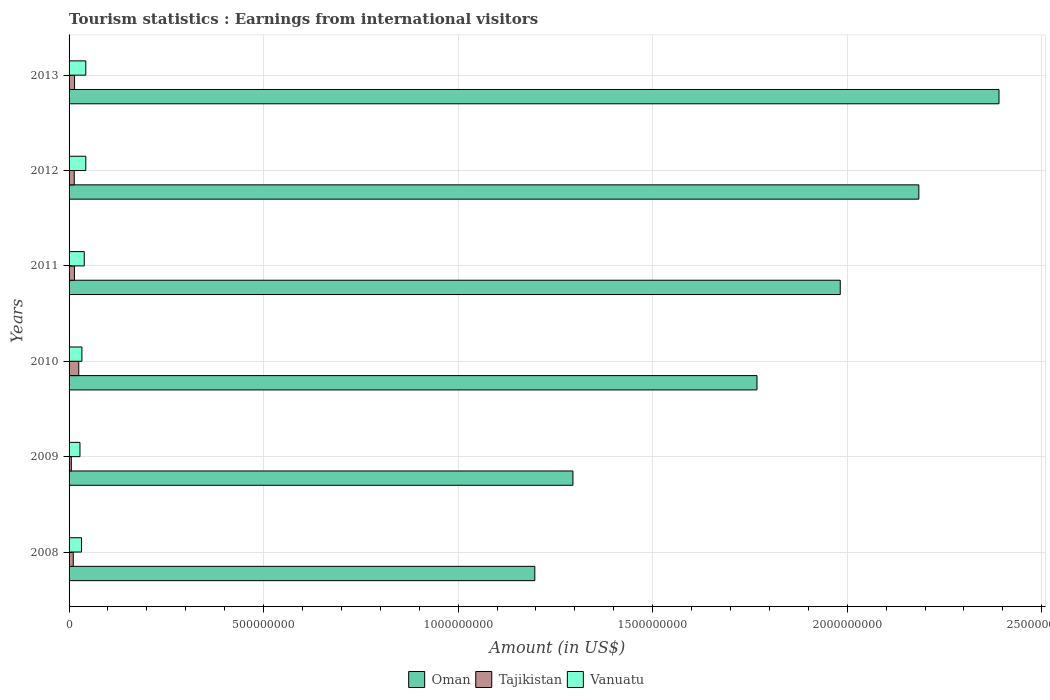Are the number of bars on each tick of the Y-axis equal?
Provide a short and direct response. Yes. How many bars are there on the 4th tick from the top?
Keep it short and to the point. 3. What is the earnings from international visitors in Vanuatu in 2010?
Your answer should be very brief. 3.30e+07. Across all years, what is the maximum earnings from international visitors in Vanuatu?
Your answer should be compact. 4.30e+07. Across all years, what is the minimum earnings from international visitors in Tajikistan?
Provide a succinct answer. 5.80e+06. In which year was the earnings from international visitors in Tajikistan minimum?
Offer a very short reply. 2009. What is the total earnings from international visitors in Tajikistan in the graph?
Provide a short and direct response. 8.27e+07. What is the difference between the earnings from international visitors in Oman in 2010 and that in 2012?
Ensure brevity in your answer.  -4.16e+08. What is the difference between the earnings from international visitors in Oman in 2011 and the earnings from international visitors in Tajikistan in 2013?
Make the answer very short. 1.97e+09. What is the average earnings from international visitors in Vanuatu per year?
Provide a short and direct response. 3.63e+07. In the year 2011, what is the difference between the earnings from international visitors in Tajikistan and earnings from international visitors in Oman?
Provide a succinct answer. -1.97e+09. In how many years, is the earnings from international visitors in Vanuatu greater than 1000000000 US$?
Offer a terse response. 0. What is the ratio of the earnings from international visitors in Oman in 2008 to that in 2010?
Your answer should be compact. 0.68. Is the earnings from international visitors in Vanuatu in 2009 less than that in 2011?
Provide a succinct answer. Yes. What is the difference between the highest and the second highest earnings from international visitors in Oman?
Your answer should be very brief. 2.06e+08. What is the difference between the highest and the lowest earnings from international visitors in Tajikistan?
Make the answer very short. 1.91e+07. In how many years, is the earnings from international visitors in Tajikistan greater than the average earnings from international visitors in Tajikistan taken over all years?
Your answer should be very brief. 3. What does the 2nd bar from the top in 2011 represents?
Ensure brevity in your answer.  Tajikistan. What does the 1st bar from the bottom in 2013 represents?
Keep it short and to the point. Oman. Is it the case that in every year, the sum of the earnings from international visitors in Oman and earnings from international visitors in Vanuatu is greater than the earnings from international visitors in Tajikistan?
Your response must be concise. Yes. How many years are there in the graph?
Provide a succinct answer. 6. Are the values on the major ticks of X-axis written in scientific E-notation?
Provide a succinct answer. No. Where does the legend appear in the graph?
Offer a terse response. Bottom center. How many legend labels are there?
Offer a terse response. 3. How are the legend labels stacked?
Your response must be concise. Horizontal. What is the title of the graph?
Offer a very short reply. Tourism statistics : Earnings from international visitors. Does "Marshall Islands" appear as one of the legend labels in the graph?
Ensure brevity in your answer.  No. What is the label or title of the Y-axis?
Make the answer very short. Years. What is the Amount (in US$) in Oman in 2008?
Make the answer very short. 1.20e+09. What is the Amount (in US$) in Tajikistan in 2008?
Give a very brief answer. 1.08e+07. What is the Amount (in US$) in Vanuatu in 2008?
Your answer should be very brief. 3.20e+07. What is the Amount (in US$) in Oman in 2009?
Your response must be concise. 1.30e+09. What is the Amount (in US$) of Tajikistan in 2009?
Ensure brevity in your answer.  5.80e+06. What is the Amount (in US$) of Vanuatu in 2009?
Provide a succinct answer. 2.80e+07. What is the Amount (in US$) in Oman in 2010?
Keep it short and to the point. 1.77e+09. What is the Amount (in US$) of Tajikistan in 2010?
Offer a very short reply. 2.49e+07. What is the Amount (in US$) of Vanuatu in 2010?
Your answer should be compact. 3.30e+07. What is the Amount (in US$) of Oman in 2011?
Give a very brief answer. 1.98e+09. What is the Amount (in US$) in Tajikistan in 2011?
Give a very brief answer. 1.38e+07. What is the Amount (in US$) in Vanuatu in 2011?
Give a very brief answer. 3.90e+07. What is the Amount (in US$) in Oman in 2012?
Give a very brief answer. 2.18e+09. What is the Amount (in US$) of Tajikistan in 2012?
Your answer should be compact. 1.33e+07. What is the Amount (in US$) of Vanuatu in 2012?
Provide a succinct answer. 4.30e+07. What is the Amount (in US$) of Oman in 2013?
Provide a short and direct response. 2.39e+09. What is the Amount (in US$) of Tajikistan in 2013?
Keep it short and to the point. 1.41e+07. What is the Amount (in US$) in Vanuatu in 2013?
Your answer should be very brief. 4.30e+07. Across all years, what is the maximum Amount (in US$) in Oman?
Make the answer very short. 2.39e+09. Across all years, what is the maximum Amount (in US$) in Tajikistan?
Your answer should be very brief. 2.49e+07. Across all years, what is the maximum Amount (in US$) of Vanuatu?
Your answer should be very brief. 4.30e+07. Across all years, what is the minimum Amount (in US$) in Oman?
Ensure brevity in your answer.  1.20e+09. Across all years, what is the minimum Amount (in US$) of Tajikistan?
Give a very brief answer. 5.80e+06. Across all years, what is the minimum Amount (in US$) in Vanuatu?
Your answer should be compact. 2.80e+07. What is the total Amount (in US$) in Oman in the graph?
Offer a very short reply. 1.08e+1. What is the total Amount (in US$) of Tajikistan in the graph?
Provide a succinct answer. 8.27e+07. What is the total Amount (in US$) in Vanuatu in the graph?
Keep it short and to the point. 2.18e+08. What is the difference between the Amount (in US$) of Oman in 2008 and that in 2009?
Your answer should be compact. -9.80e+07. What is the difference between the Amount (in US$) of Vanuatu in 2008 and that in 2009?
Your answer should be very brief. 4.00e+06. What is the difference between the Amount (in US$) of Oman in 2008 and that in 2010?
Offer a very short reply. -5.71e+08. What is the difference between the Amount (in US$) in Tajikistan in 2008 and that in 2010?
Your response must be concise. -1.41e+07. What is the difference between the Amount (in US$) in Oman in 2008 and that in 2011?
Keep it short and to the point. -7.85e+08. What is the difference between the Amount (in US$) in Vanuatu in 2008 and that in 2011?
Provide a short and direct response. -7.00e+06. What is the difference between the Amount (in US$) in Oman in 2008 and that in 2012?
Your answer should be compact. -9.87e+08. What is the difference between the Amount (in US$) in Tajikistan in 2008 and that in 2012?
Provide a short and direct response. -2.50e+06. What is the difference between the Amount (in US$) of Vanuatu in 2008 and that in 2012?
Provide a succinct answer. -1.10e+07. What is the difference between the Amount (in US$) of Oman in 2008 and that in 2013?
Your response must be concise. -1.19e+09. What is the difference between the Amount (in US$) in Tajikistan in 2008 and that in 2013?
Your answer should be very brief. -3.30e+06. What is the difference between the Amount (in US$) in Vanuatu in 2008 and that in 2013?
Provide a short and direct response. -1.10e+07. What is the difference between the Amount (in US$) of Oman in 2009 and that in 2010?
Give a very brief answer. -4.73e+08. What is the difference between the Amount (in US$) in Tajikistan in 2009 and that in 2010?
Your answer should be very brief. -1.91e+07. What is the difference between the Amount (in US$) in Vanuatu in 2009 and that in 2010?
Your response must be concise. -5.00e+06. What is the difference between the Amount (in US$) of Oman in 2009 and that in 2011?
Ensure brevity in your answer.  -6.87e+08. What is the difference between the Amount (in US$) in Tajikistan in 2009 and that in 2011?
Keep it short and to the point. -8.00e+06. What is the difference between the Amount (in US$) of Vanuatu in 2009 and that in 2011?
Your answer should be very brief. -1.10e+07. What is the difference between the Amount (in US$) of Oman in 2009 and that in 2012?
Give a very brief answer. -8.89e+08. What is the difference between the Amount (in US$) of Tajikistan in 2009 and that in 2012?
Provide a short and direct response. -7.50e+06. What is the difference between the Amount (in US$) of Vanuatu in 2009 and that in 2012?
Make the answer very short. -1.50e+07. What is the difference between the Amount (in US$) of Oman in 2009 and that in 2013?
Make the answer very short. -1.10e+09. What is the difference between the Amount (in US$) in Tajikistan in 2009 and that in 2013?
Your answer should be very brief. -8.30e+06. What is the difference between the Amount (in US$) of Vanuatu in 2009 and that in 2013?
Your response must be concise. -1.50e+07. What is the difference between the Amount (in US$) of Oman in 2010 and that in 2011?
Make the answer very short. -2.14e+08. What is the difference between the Amount (in US$) of Tajikistan in 2010 and that in 2011?
Your answer should be very brief. 1.11e+07. What is the difference between the Amount (in US$) of Vanuatu in 2010 and that in 2011?
Your answer should be very brief. -6.00e+06. What is the difference between the Amount (in US$) in Oman in 2010 and that in 2012?
Provide a short and direct response. -4.16e+08. What is the difference between the Amount (in US$) in Tajikistan in 2010 and that in 2012?
Ensure brevity in your answer.  1.16e+07. What is the difference between the Amount (in US$) in Vanuatu in 2010 and that in 2012?
Offer a terse response. -1.00e+07. What is the difference between the Amount (in US$) in Oman in 2010 and that in 2013?
Provide a succinct answer. -6.22e+08. What is the difference between the Amount (in US$) of Tajikistan in 2010 and that in 2013?
Provide a short and direct response. 1.08e+07. What is the difference between the Amount (in US$) in Vanuatu in 2010 and that in 2013?
Your answer should be very brief. -1.00e+07. What is the difference between the Amount (in US$) in Oman in 2011 and that in 2012?
Offer a terse response. -2.02e+08. What is the difference between the Amount (in US$) in Oman in 2011 and that in 2013?
Make the answer very short. -4.08e+08. What is the difference between the Amount (in US$) in Oman in 2012 and that in 2013?
Ensure brevity in your answer.  -2.06e+08. What is the difference between the Amount (in US$) of Tajikistan in 2012 and that in 2013?
Your answer should be very brief. -8.00e+05. What is the difference between the Amount (in US$) of Vanuatu in 2012 and that in 2013?
Give a very brief answer. 0. What is the difference between the Amount (in US$) in Oman in 2008 and the Amount (in US$) in Tajikistan in 2009?
Your answer should be compact. 1.19e+09. What is the difference between the Amount (in US$) in Oman in 2008 and the Amount (in US$) in Vanuatu in 2009?
Offer a terse response. 1.17e+09. What is the difference between the Amount (in US$) of Tajikistan in 2008 and the Amount (in US$) of Vanuatu in 2009?
Provide a succinct answer. -1.72e+07. What is the difference between the Amount (in US$) in Oman in 2008 and the Amount (in US$) in Tajikistan in 2010?
Your response must be concise. 1.17e+09. What is the difference between the Amount (in US$) of Oman in 2008 and the Amount (in US$) of Vanuatu in 2010?
Offer a very short reply. 1.16e+09. What is the difference between the Amount (in US$) of Tajikistan in 2008 and the Amount (in US$) of Vanuatu in 2010?
Make the answer very short. -2.22e+07. What is the difference between the Amount (in US$) in Oman in 2008 and the Amount (in US$) in Tajikistan in 2011?
Your answer should be very brief. 1.18e+09. What is the difference between the Amount (in US$) of Oman in 2008 and the Amount (in US$) of Vanuatu in 2011?
Ensure brevity in your answer.  1.16e+09. What is the difference between the Amount (in US$) in Tajikistan in 2008 and the Amount (in US$) in Vanuatu in 2011?
Your answer should be compact. -2.82e+07. What is the difference between the Amount (in US$) in Oman in 2008 and the Amount (in US$) in Tajikistan in 2012?
Make the answer very short. 1.18e+09. What is the difference between the Amount (in US$) of Oman in 2008 and the Amount (in US$) of Vanuatu in 2012?
Keep it short and to the point. 1.15e+09. What is the difference between the Amount (in US$) of Tajikistan in 2008 and the Amount (in US$) of Vanuatu in 2012?
Offer a very short reply. -3.22e+07. What is the difference between the Amount (in US$) of Oman in 2008 and the Amount (in US$) of Tajikistan in 2013?
Your answer should be compact. 1.18e+09. What is the difference between the Amount (in US$) in Oman in 2008 and the Amount (in US$) in Vanuatu in 2013?
Provide a short and direct response. 1.15e+09. What is the difference between the Amount (in US$) of Tajikistan in 2008 and the Amount (in US$) of Vanuatu in 2013?
Provide a succinct answer. -3.22e+07. What is the difference between the Amount (in US$) of Oman in 2009 and the Amount (in US$) of Tajikistan in 2010?
Keep it short and to the point. 1.27e+09. What is the difference between the Amount (in US$) in Oman in 2009 and the Amount (in US$) in Vanuatu in 2010?
Your answer should be very brief. 1.26e+09. What is the difference between the Amount (in US$) in Tajikistan in 2009 and the Amount (in US$) in Vanuatu in 2010?
Your response must be concise. -2.72e+07. What is the difference between the Amount (in US$) in Oman in 2009 and the Amount (in US$) in Tajikistan in 2011?
Ensure brevity in your answer.  1.28e+09. What is the difference between the Amount (in US$) of Oman in 2009 and the Amount (in US$) of Vanuatu in 2011?
Provide a short and direct response. 1.26e+09. What is the difference between the Amount (in US$) in Tajikistan in 2009 and the Amount (in US$) in Vanuatu in 2011?
Provide a short and direct response. -3.32e+07. What is the difference between the Amount (in US$) of Oman in 2009 and the Amount (in US$) of Tajikistan in 2012?
Your answer should be compact. 1.28e+09. What is the difference between the Amount (in US$) of Oman in 2009 and the Amount (in US$) of Vanuatu in 2012?
Your answer should be very brief. 1.25e+09. What is the difference between the Amount (in US$) of Tajikistan in 2009 and the Amount (in US$) of Vanuatu in 2012?
Keep it short and to the point. -3.72e+07. What is the difference between the Amount (in US$) in Oman in 2009 and the Amount (in US$) in Tajikistan in 2013?
Ensure brevity in your answer.  1.28e+09. What is the difference between the Amount (in US$) of Oman in 2009 and the Amount (in US$) of Vanuatu in 2013?
Offer a terse response. 1.25e+09. What is the difference between the Amount (in US$) in Tajikistan in 2009 and the Amount (in US$) in Vanuatu in 2013?
Provide a short and direct response. -3.72e+07. What is the difference between the Amount (in US$) of Oman in 2010 and the Amount (in US$) of Tajikistan in 2011?
Provide a succinct answer. 1.75e+09. What is the difference between the Amount (in US$) of Oman in 2010 and the Amount (in US$) of Vanuatu in 2011?
Offer a very short reply. 1.73e+09. What is the difference between the Amount (in US$) in Tajikistan in 2010 and the Amount (in US$) in Vanuatu in 2011?
Offer a terse response. -1.41e+07. What is the difference between the Amount (in US$) in Oman in 2010 and the Amount (in US$) in Tajikistan in 2012?
Your answer should be compact. 1.75e+09. What is the difference between the Amount (in US$) in Oman in 2010 and the Amount (in US$) in Vanuatu in 2012?
Keep it short and to the point. 1.72e+09. What is the difference between the Amount (in US$) of Tajikistan in 2010 and the Amount (in US$) of Vanuatu in 2012?
Offer a terse response. -1.81e+07. What is the difference between the Amount (in US$) in Oman in 2010 and the Amount (in US$) in Tajikistan in 2013?
Offer a terse response. 1.75e+09. What is the difference between the Amount (in US$) of Oman in 2010 and the Amount (in US$) of Vanuatu in 2013?
Provide a short and direct response. 1.72e+09. What is the difference between the Amount (in US$) in Tajikistan in 2010 and the Amount (in US$) in Vanuatu in 2013?
Provide a short and direct response. -1.81e+07. What is the difference between the Amount (in US$) of Oman in 2011 and the Amount (in US$) of Tajikistan in 2012?
Your answer should be compact. 1.97e+09. What is the difference between the Amount (in US$) of Oman in 2011 and the Amount (in US$) of Vanuatu in 2012?
Your response must be concise. 1.94e+09. What is the difference between the Amount (in US$) of Tajikistan in 2011 and the Amount (in US$) of Vanuatu in 2012?
Your answer should be compact. -2.92e+07. What is the difference between the Amount (in US$) in Oman in 2011 and the Amount (in US$) in Tajikistan in 2013?
Give a very brief answer. 1.97e+09. What is the difference between the Amount (in US$) of Oman in 2011 and the Amount (in US$) of Vanuatu in 2013?
Keep it short and to the point. 1.94e+09. What is the difference between the Amount (in US$) of Tajikistan in 2011 and the Amount (in US$) of Vanuatu in 2013?
Your answer should be compact. -2.92e+07. What is the difference between the Amount (in US$) of Oman in 2012 and the Amount (in US$) of Tajikistan in 2013?
Ensure brevity in your answer.  2.17e+09. What is the difference between the Amount (in US$) in Oman in 2012 and the Amount (in US$) in Vanuatu in 2013?
Ensure brevity in your answer.  2.14e+09. What is the difference between the Amount (in US$) in Tajikistan in 2012 and the Amount (in US$) in Vanuatu in 2013?
Your answer should be compact. -2.97e+07. What is the average Amount (in US$) in Oman per year?
Offer a very short reply. 1.80e+09. What is the average Amount (in US$) of Tajikistan per year?
Offer a very short reply. 1.38e+07. What is the average Amount (in US$) of Vanuatu per year?
Your answer should be compact. 3.63e+07. In the year 2008, what is the difference between the Amount (in US$) of Oman and Amount (in US$) of Tajikistan?
Make the answer very short. 1.19e+09. In the year 2008, what is the difference between the Amount (in US$) in Oman and Amount (in US$) in Vanuatu?
Your answer should be compact. 1.16e+09. In the year 2008, what is the difference between the Amount (in US$) in Tajikistan and Amount (in US$) in Vanuatu?
Provide a short and direct response. -2.12e+07. In the year 2009, what is the difference between the Amount (in US$) of Oman and Amount (in US$) of Tajikistan?
Ensure brevity in your answer.  1.29e+09. In the year 2009, what is the difference between the Amount (in US$) in Oman and Amount (in US$) in Vanuatu?
Offer a terse response. 1.27e+09. In the year 2009, what is the difference between the Amount (in US$) in Tajikistan and Amount (in US$) in Vanuatu?
Keep it short and to the point. -2.22e+07. In the year 2010, what is the difference between the Amount (in US$) in Oman and Amount (in US$) in Tajikistan?
Give a very brief answer. 1.74e+09. In the year 2010, what is the difference between the Amount (in US$) in Oman and Amount (in US$) in Vanuatu?
Your answer should be compact. 1.74e+09. In the year 2010, what is the difference between the Amount (in US$) in Tajikistan and Amount (in US$) in Vanuatu?
Offer a terse response. -8.10e+06. In the year 2011, what is the difference between the Amount (in US$) in Oman and Amount (in US$) in Tajikistan?
Provide a succinct answer. 1.97e+09. In the year 2011, what is the difference between the Amount (in US$) in Oman and Amount (in US$) in Vanuatu?
Ensure brevity in your answer.  1.94e+09. In the year 2011, what is the difference between the Amount (in US$) in Tajikistan and Amount (in US$) in Vanuatu?
Your answer should be compact. -2.52e+07. In the year 2012, what is the difference between the Amount (in US$) of Oman and Amount (in US$) of Tajikistan?
Make the answer very short. 2.17e+09. In the year 2012, what is the difference between the Amount (in US$) of Oman and Amount (in US$) of Vanuatu?
Provide a short and direct response. 2.14e+09. In the year 2012, what is the difference between the Amount (in US$) in Tajikistan and Amount (in US$) in Vanuatu?
Keep it short and to the point. -2.97e+07. In the year 2013, what is the difference between the Amount (in US$) of Oman and Amount (in US$) of Tajikistan?
Your answer should be very brief. 2.38e+09. In the year 2013, what is the difference between the Amount (in US$) in Oman and Amount (in US$) in Vanuatu?
Keep it short and to the point. 2.35e+09. In the year 2013, what is the difference between the Amount (in US$) in Tajikistan and Amount (in US$) in Vanuatu?
Provide a succinct answer. -2.89e+07. What is the ratio of the Amount (in US$) in Oman in 2008 to that in 2009?
Offer a terse response. 0.92. What is the ratio of the Amount (in US$) in Tajikistan in 2008 to that in 2009?
Make the answer very short. 1.86. What is the ratio of the Amount (in US$) in Vanuatu in 2008 to that in 2009?
Offer a very short reply. 1.14. What is the ratio of the Amount (in US$) in Oman in 2008 to that in 2010?
Offer a terse response. 0.68. What is the ratio of the Amount (in US$) of Tajikistan in 2008 to that in 2010?
Provide a succinct answer. 0.43. What is the ratio of the Amount (in US$) in Vanuatu in 2008 to that in 2010?
Your response must be concise. 0.97. What is the ratio of the Amount (in US$) of Oman in 2008 to that in 2011?
Offer a terse response. 0.6. What is the ratio of the Amount (in US$) in Tajikistan in 2008 to that in 2011?
Give a very brief answer. 0.78. What is the ratio of the Amount (in US$) of Vanuatu in 2008 to that in 2011?
Your answer should be compact. 0.82. What is the ratio of the Amount (in US$) in Oman in 2008 to that in 2012?
Offer a very short reply. 0.55. What is the ratio of the Amount (in US$) of Tajikistan in 2008 to that in 2012?
Ensure brevity in your answer.  0.81. What is the ratio of the Amount (in US$) of Vanuatu in 2008 to that in 2012?
Offer a terse response. 0.74. What is the ratio of the Amount (in US$) in Oman in 2008 to that in 2013?
Your response must be concise. 0.5. What is the ratio of the Amount (in US$) in Tajikistan in 2008 to that in 2013?
Provide a succinct answer. 0.77. What is the ratio of the Amount (in US$) in Vanuatu in 2008 to that in 2013?
Provide a succinct answer. 0.74. What is the ratio of the Amount (in US$) in Oman in 2009 to that in 2010?
Ensure brevity in your answer.  0.73. What is the ratio of the Amount (in US$) of Tajikistan in 2009 to that in 2010?
Ensure brevity in your answer.  0.23. What is the ratio of the Amount (in US$) of Vanuatu in 2009 to that in 2010?
Provide a succinct answer. 0.85. What is the ratio of the Amount (in US$) in Oman in 2009 to that in 2011?
Your answer should be very brief. 0.65. What is the ratio of the Amount (in US$) in Tajikistan in 2009 to that in 2011?
Your response must be concise. 0.42. What is the ratio of the Amount (in US$) in Vanuatu in 2009 to that in 2011?
Your answer should be compact. 0.72. What is the ratio of the Amount (in US$) in Oman in 2009 to that in 2012?
Make the answer very short. 0.59. What is the ratio of the Amount (in US$) of Tajikistan in 2009 to that in 2012?
Offer a terse response. 0.44. What is the ratio of the Amount (in US$) of Vanuatu in 2009 to that in 2012?
Provide a short and direct response. 0.65. What is the ratio of the Amount (in US$) of Oman in 2009 to that in 2013?
Provide a short and direct response. 0.54. What is the ratio of the Amount (in US$) of Tajikistan in 2009 to that in 2013?
Offer a very short reply. 0.41. What is the ratio of the Amount (in US$) of Vanuatu in 2009 to that in 2013?
Your answer should be compact. 0.65. What is the ratio of the Amount (in US$) in Oman in 2010 to that in 2011?
Keep it short and to the point. 0.89. What is the ratio of the Amount (in US$) in Tajikistan in 2010 to that in 2011?
Make the answer very short. 1.8. What is the ratio of the Amount (in US$) of Vanuatu in 2010 to that in 2011?
Ensure brevity in your answer.  0.85. What is the ratio of the Amount (in US$) in Oman in 2010 to that in 2012?
Provide a short and direct response. 0.81. What is the ratio of the Amount (in US$) of Tajikistan in 2010 to that in 2012?
Give a very brief answer. 1.87. What is the ratio of the Amount (in US$) in Vanuatu in 2010 to that in 2012?
Make the answer very short. 0.77. What is the ratio of the Amount (in US$) of Oman in 2010 to that in 2013?
Your answer should be very brief. 0.74. What is the ratio of the Amount (in US$) in Tajikistan in 2010 to that in 2013?
Ensure brevity in your answer.  1.77. What is the ratio of the Amount (in US$) of Vanuatu in 2010 to that in 2013?
Ensure brevity in your answer.  0.77. What is the ratio of the Amount (in US$) of Oman in 2011 to that in 2012?
Offer a very short reply. 0.91. What is the ratio of the Amount (in US$) of Tajikistan in 2011 to that in 2012?
Your response must be concise. 1.04. What is the ratio of the Amount (in US$) of Vanuatu in 2011 to that in 2012?
Make the answer very short. 0.91. What is the ratio of the Amount (in US$) of Oman in 2011 to that in 2013?
Provide a short and direct response. 0.83. What is the ratio of the Amount (in US$) of Tajikistan in 2011 to that in 2013?
Ensure brevity in your answer.  0.98. What is the ratio of the Amount (in US$) in Vanuatu in 2011 to that in 2013?
Make the answer very short. 0.91. What is the ratio of the Amount (in US$) of Oman in 2012 to that in 2013?
Provide a succinct answer. 0.91. What is the ratio of the Amount (in US$) of Tajikistan in 2012 to that in 2013?
Your answer should be compact. 0.94. What is the difference between the highest and the second highest Amount (in US$) in Oman?
Make the answer very short. 2.06e+08. What is the difference between the highest and the second highest Amount (in US$) of Tajikistan?
Keep it short and to the point. 1.08e+07. What is the difference between the highest and the second highest Amount (in US$) in Vanuatu?
Your answer should be compact. 0. What is the difference between the highest and the lowest Amount (in US$) in Oman?
Your answer should be very brief. 1.19e+09. What is the difference between the highest and the lowest Amount (in US$) in Tajikistan?
Offer a very short reply. 1.91e+07. What is the difference between the highest and the lowest Amount (in US$) of Vanuatu?
Make the answer very short. 1.50e+07. 